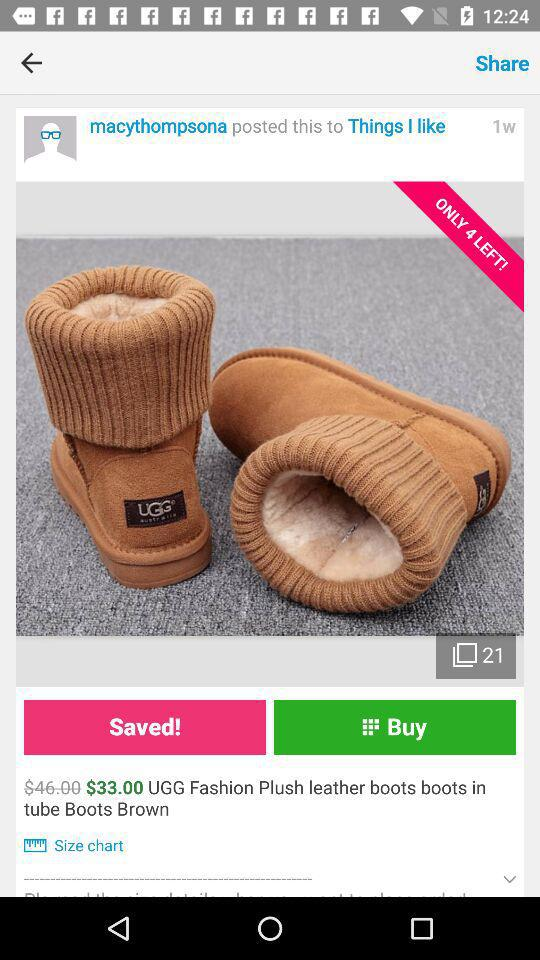What is the original price of the leather boots? The original price is $46. 